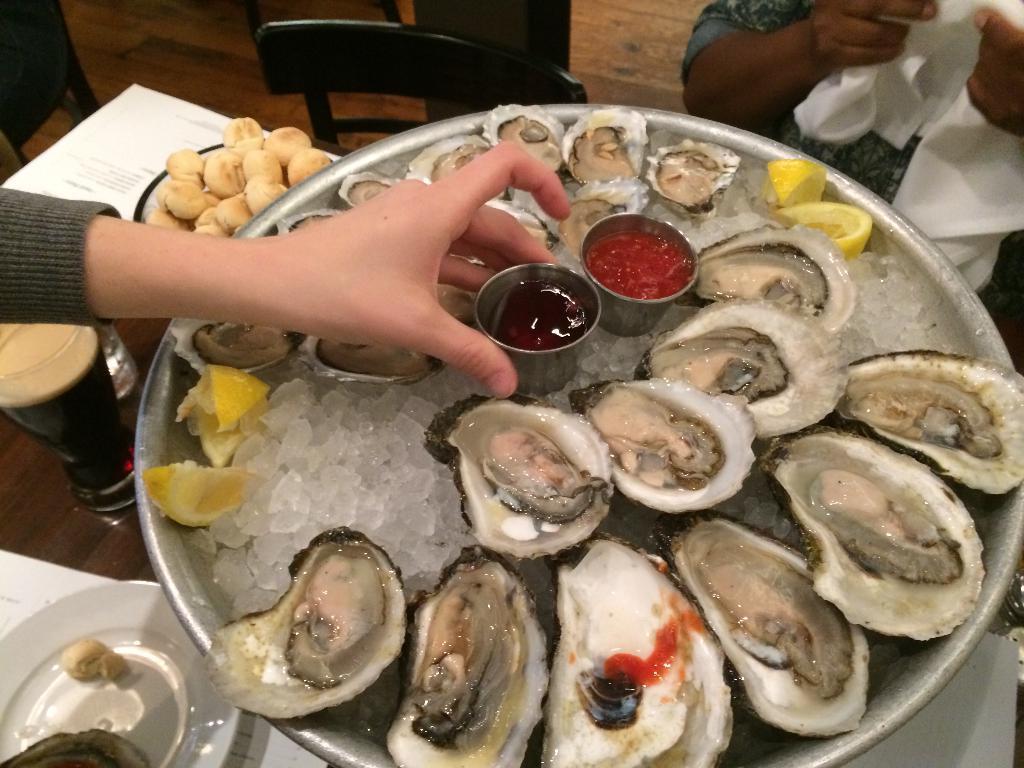Can you describe this image briefly? In this picture there is a plate which contains abalones in it and there are other food items which are placed on the table, there is a chair at the top side of the image and there is a person in the top right side of the image and there is another person on the left side of the image. 